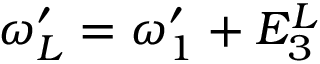Convert formula to latex. <formula><loc_0><loc_0><loc_500><loc_500>\omega _ { L } ^ { \prime } = \omega _ { 1 } ^ { \prime } + E _ { 3 } ^ { L }</formula> 